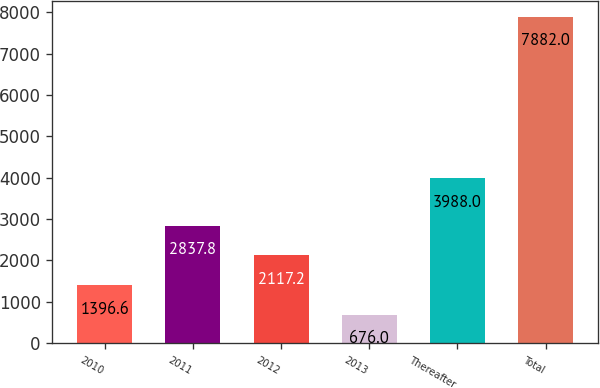Convert chart. <chart><loc_0><loc_0><loc_500><loc_500><bar_chart><fcel>2010<fcel>2011<fcel>2012<fcel>2013<fcel>Thereafter<fcel>Total<nl><fcel>1396.6<fcel>2837.8<fcel>2117.2<fcel>676<fcel>3988<fcel>7882<nl></chart> 